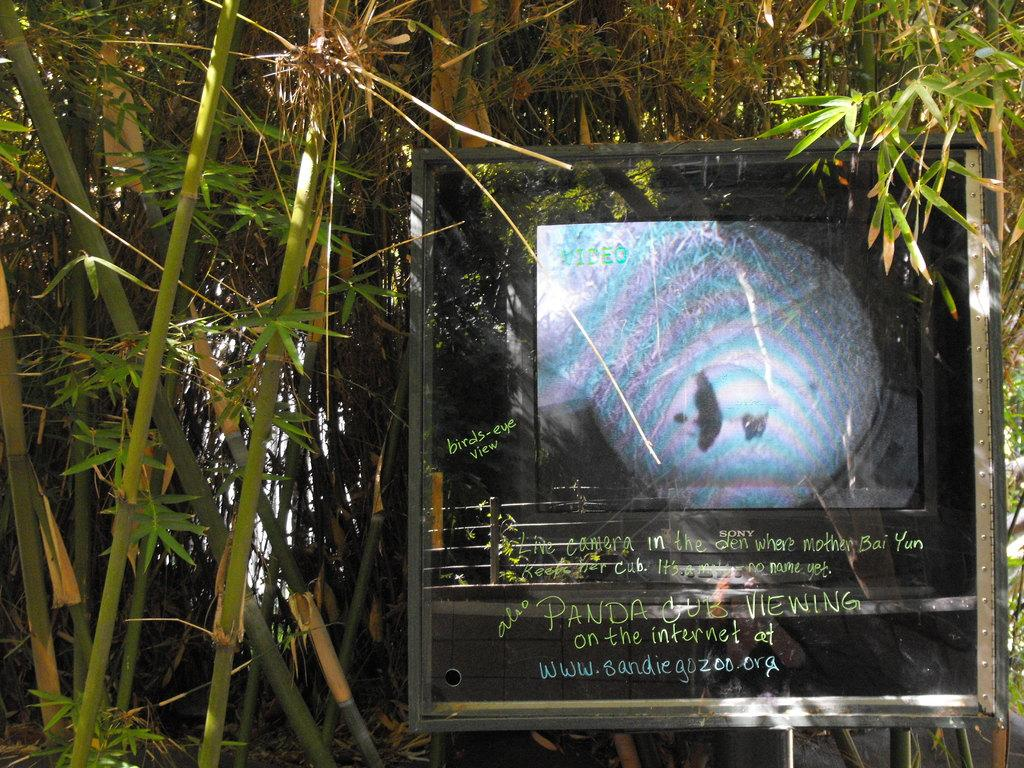What is the primary feature of the image? The primary feature of the image is the many trees. What object is located in the middle of the image? There is a board in the middle of the image. What can be found on the board? There is something written on the board. How many cherries are hanging from the trees in the image? There is no mention of cherries in the image, so we cannot determine the number of cherries present. What type of plastic material can be seen in the image? There is no plastic material mentioned in the image. 